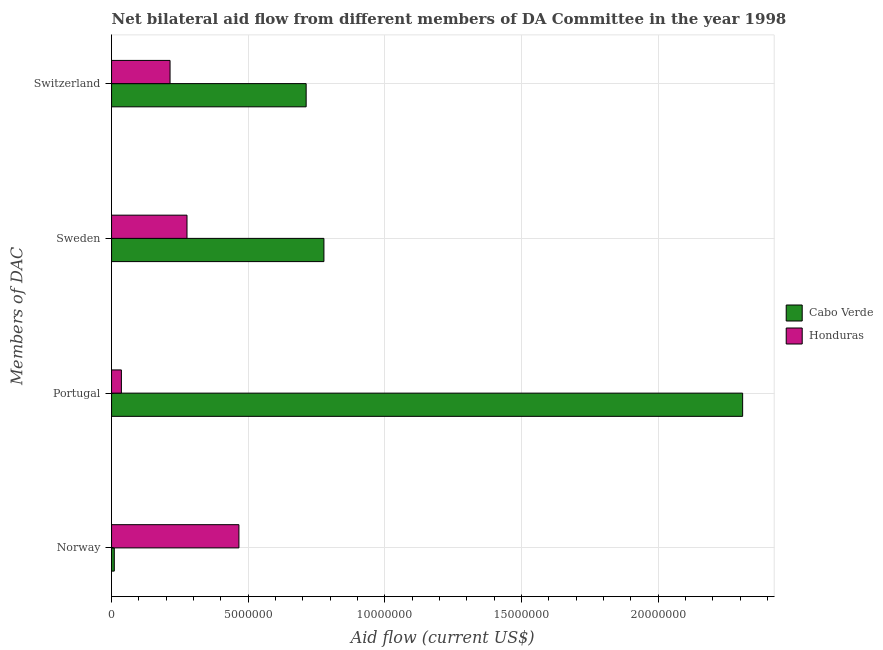How many different coloured bars are there?
Provide a succinct answer. 2. How many groups of bars are there?
Your answer should be very brief. 4. Are the number of bars per tick equal to the number of legend labels?
Keep it short and to the point. Yes. How many bars are there on the 4th tick from the top?
Your answer should be compact. 2. What is the label of the 1st group of bars from the top?
Provide a short and direct response. Switzerland. What is the amount of aid given by switzerland in Honduras?
Make the answer very short. 2.14e+06. Across all countries, what is the maximum amount of aid given by sweden?
Keep it short and to the point. 7.77e+06. Across all countries, what is the minimum amount of aid given by sweden?
Give a very brief answer. 2.76e+06. In which country was the amount of aid given by norway maximum?
Make the answer very short. Honduras. In which country was the amount of aid given by sweden minimum?
Give a very brief answer. Honduras. What is the total amount of aid given by sweden in the graph?
Keep it short and to the point. 1.05e+07. What is the difference between the amount of aid given by portugal in Honduras and that in Cabo Verde?
Your response must be concise. -2.27e+07. What is the difference between the amount of aid given by sweden in Honduras and the amount of aid given by switzerland in Cabo Verde?
Ensure brevity in your answer.  -4.36e+06. What is the average amount of aid given by portugal per country?
Offer a terse response. 1.17e+07. What is the difference between the amount of aid given by switzerland and amount of aid given by portugal in Honduras?
Your response must be concise. 1.78e+06. In how many countries, is the amount of aid given by sweden greater than 21000000 US$?
Your answer should be compact. 0. What is the ratio of the amount of aid given by norway in Honduras to that in Cabo Verde?
Your answer should be very brief. 46.6. Is the amount of aid given by sweden in Cabo Verde less than that in Honduras?
Your answer should be compact. No. What is the difference between the highest and the second highest amount of aid given by switzerland?
Your answer should be very brief. 4.98e+06. What is the difference between the highest and the lowest amount of aid given by portugal?
Make the answer very short. 2.27e+07. Is the sum of the amount of aid given by portugal in Honduras and Cabo Verde greater than the maximum amount of aid given by norway across all countries?
Make the answer very short. Yes. What does the 1st bar from the top in Sweden represents?
Ensure brevity in your answer.  Honduras. What does the 2nd bar from the bottom in Portugal represents?
Make the answer very short. Honduras. What is the difference between two consecutive major ticks on the X-axis?
Give a very brief answer. 5.00e+06. Does the graph contain any zero values?
Your answer should be very brief. No. Does the graph contain grids?
Make the answer very short. Yes. Where does the legend appear in the graph?
Your response must be concise. Center right. What is the title of the graph?
Provide a short and direct response. Net bilateral aid flow from different members of DA Committee in the year 1998. What is the label or title of the X-axis?
Offer a terse response. Aid flow (current US$). What is the label or title of the Y-axis?
Provide a short and direct response. Members of DAC. What is the Aid flow (current US$) in Cabo Verde in Norway?
Your response must be concise. 1.00e+05. What is the Aid flow (current US$) of Honduras in Norway?
Ensure brevity in your answer.  4.66e+06. What is the Aid flow (current US$) of Cabo Verde in Portugal?
Your answer should be very brief. 2.31e+07. What is the Aid flow (current US$) in Cabo Verde in Sweden?
Provide a short and direct response. 7.77e+06. What is the Aid flow (current US$) in Honduras in Sweden?
Give a very brief answer. 2.76e+06. What is the Aid flow (current US$) in Cabo Verde in Switzerland?
Make the answer very short. 7.12e+06. What is the Aid flow (current US$) in Honduras in Switzerland?
Provide a succinct answer. 2.14e+06. Across all Members of DAC, what is the maximum Aid flow (current US$) of Cabo Verde?
Ensure brevity in your answer.  2.31e+07. Across all Members of DAC, what is the maximum Aid flow (current US$) in Honduras?
Provide a succinct answer. 4.66e+06. Across all Members of DAC, what is the minimum Aid flow (current US$) in Cabo Verde?
Offer a very short reply. 1.00e+05. What is the total Aid flow (current US$) of Cabo Verde in the graph?
Ensure brevity in your answer.  3.81e+07. What is the total Aid flow (current US$) in Honduras in the graph?
Make the answer very short. 9.92e+06. What is the difference between the Aid flow (current US$) of Cabo Verde in Norway and that in Portugal?
Offer a terse response. -2.30e+07. What is the difference between the Aid flow (current US$) of Honduras in Norway and that in Portugal?
Ensure brevity in your answer.  4.30e+06. What is the difference between the Aid flow (current US$) of Cabo Verde in Norway and that in Sweden?
Make the answer very short. -7.67e+06. What is the difference between the Aid flow (current US$) of Honduras in Norway and that in Sweden?
Keep it short and to the point. 1.90e+06. What is the difference between the Aid flow (current US$) in Cabo Verde in Norway and that in Switzerland?
Your answer should be very brief. -7.02e+06. What is the difference between the Aid flow (current US$) in Honduras in Norway and that in Switzerland?
Ensure brevity in your answer.  2.52e+06. What is the difference between the Aid flow (current US$) of Cabo Verde in Portugal and that in Sweden?
Make the answer very short. 1.53e+07. What is the difference between the Aid flow (current US$) in Honduras in Portugal and that in Sweden?
Give a very brief answer. -2.40e+06. What is the difference between the Aid flow (current US$) in Cabo Verde in Portugal and that in Switzerland?
Keep it short and to the point. 1.60e+07. What is the difference between the Aid flow (current US$) in Honduras in Portugal and that in Switzerland?
Give a very brief answer. -1.78e+06. What is the difference between the Aid flow (current US$) in Cabo Verde in Sweden and that in Switzerland?
Keep it short and to the point. 6.50e+05. What is the difference between the Aid flow (current US$) of Honduras in Sweden and that in Switzerland?
Offer a very short reply. 6.20e+05. What is the difference between the Aid flow (current US$) of Cabo Verde in Norway and the Aid flow (current US$) of Honduras in Portugal?
Provide a succinct answer. -2.60e+05. What is the difference between the Aid flow (current US$) of Cabo Verde in Norway and the Aid flow (current US$) of Honduras in Sweden?
Give a very brief answer. -2.66e+06. What is the difference between the Aid flow (current US$) of Cabo Verde in Norway and the Aid flow (current US$) of Honduras in Switzerland?
Provide a succinct answer. -2.04e+06. What is the difference between the Aid flow (current US$) of Cabo Verde in Portugal and the Aid flow (current US$) of Honduras in Sweden?
Offer a very short reply. 2.03e+07. What is the difference between the Aid flow (current US$) in Cabo Verde in Portugal and the Aid flow (current US$) in Honduras in Switzerland?
Make the answer very short. 2.10e+07. What is the difference between the Aid flow (current US$) in Cabo Verde in Sweden and the Aid flow (current US$) in Honduras in Switzerland?
Offer a very short reply. 5.63e+06. What is the average Aid flow (current US$) of Cabo Verde per Members of DAC?
Offer a very short reply. 9.52e+06. What is the average Aid flow (current US$) in Honduras per Members of DAC?
Provide a short and direct response. 2.48e+06. What is the difference between the Aid flow (current US$) of Cabo Verde and Aid flow (current US$) of Honduras in Norway?
Your response must be concise. -4.56e+06. What is the difference between the Aid flow (current US$) of Cabo Verde and Aid flow (current US$) of Honduras in Portugal?
Provide a succinct answer. 2.27e+07. What is the difference between the Aid flow (current US$) of Cabo Verde and Aid flow (current US$) of Honduras in Sweden?
Give a very brief answer. 5.01e+06. What is the difference between the Aid flow (current US$) in Cabo Verde and Aid flow (current US$) in Honduras in Switzerland?
Your answer should be very brief. 4.98e+06. What is the ratio of the Aid flow (current US$) of Cabo Verde in Norway to that in Portugal?
Provide a short and direct response. 0. What is the ratio of the Aid flow (current US$) in Honduras in Norway to that in Portugal?
Ensure brevity in your answer.  12.94. What is the ratio of the Aid flow (current US$) of Cabo Verde in Norway to that in Sweden?
Provide a short and direct response. 0.01. What is the ratio of the Aid flow (current US$) of Honduras in Norway to that in Sweden?
Provide a short and direct response. 1.69. What is the ratio of the Aid flow (current US$) of Cabo Verde in Norway to that in Switzerland?
Your answer should be very brief. 0.01. What is the ratio of the Aid flow (current US$) of Honduras in Norway to that in Switzerland?
Provide a succinct answer. 2.18. What is the ratio of the Aid flow (current US$) in Cabo Verde in Portugal to that in Sweden?
Offer a very short reply. 2.97. What is the ratio of the Aid flow (current US$) of Honduras in Portugal to that in Sweden?
Give a very brief answer. 0.13. What is the ratio of the Aid flow (current US$) of Cabo Verde in Portugal to that in Switzerland?
Provide a succinct answer. 3.24. What is the ratio of the Aid flow (current US$) in Honduras in Portugal to that in Switzerland?
Provide a succinct answer. 0.17. What is the ratio of the Aid flow (current US$) of Cabo Verde in Sweden to that in Switzerland?
Make the answer very short. 1.09. What is the ratio of the Aid flow (current US$) in Honduras in Sweden to that in Switzerland?
Your answer should be compact. 1.29. What is the difference between the highest and the second highest Aid flow (current US$) in Cabo Verde?
Your answer should be very brief. 1.53e+07. What is the difference between the highest and the second highest Aid flow (current US$) in Honduras?
Ensure brevity in your answer.  1.90e+06. What is the difference between the highest and the lowest Aid flow (current US$) of Cabo Verde?
Give a very brief answer. 2.30e+07. What is the difference between the highest and the lowest Aid flow (current US$) in Honduras?
Your answer should be very brief. 4.30e+06. 